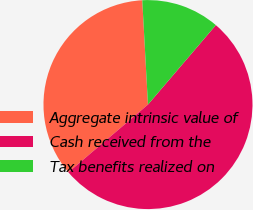<chart> <loc_0><loc_0><loc_500><loc_500><pie_chart><fcel>Aggregate intrinsic value of<fcel>Cash received from the<fcel>Tax benefits realized on<nl><fcel>35.35%<fcel>52.53%<fcel>12.12%<nl></chart> 